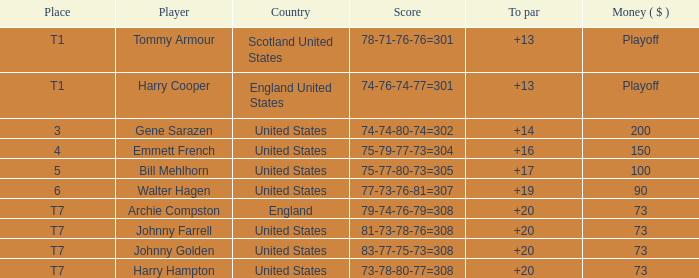What is the united states' tally when harry hampton is the athlete and the cash is $73? 73-78-80-77=308. 